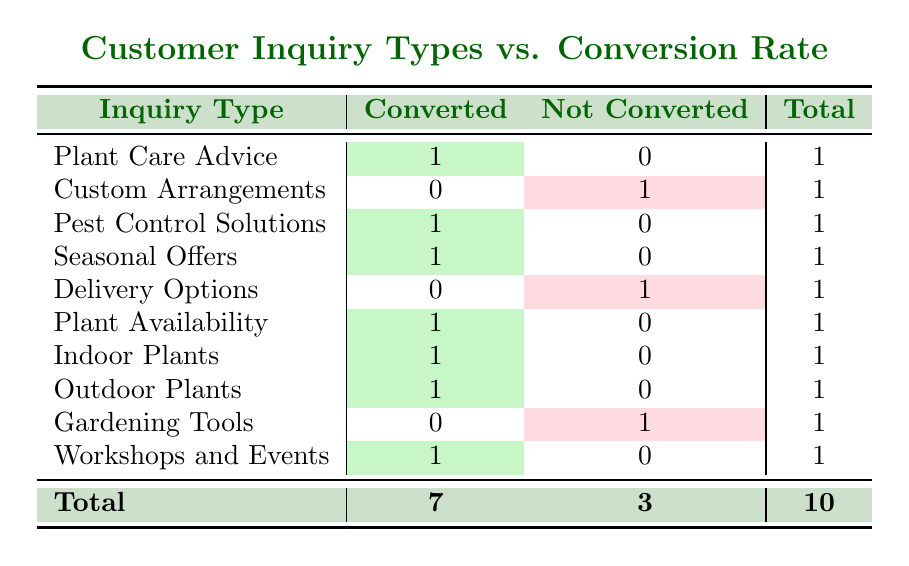What is the total number of inquiries? To find the total number of inquiries, we can look at the "Total" column at the bottom of the table, which sums up all the inquiries. The total is listed as 10.
Answer: 10 How many inquiry types resulted in a conversion to sale? We can look at the "Converted" column and count the number of rows where the value is 1. By counting the highlighted cells in the "Converted" column, we identify 7 inquiries that converted to sales.
Answer: 7 What was the conversion rate for Custom Arrangements? The conversion rate for Custom Arrangements can be determined by checking its row. It shows a "Not Converted" status with a 1 in the "Not Converted" column, indicating zero conversions out of one inquiry. Thus, the conversion rate is 0%.
Answer: 0% Which inquiry type had the highest conversion rate? To identify the inquiry type with the highest conversion rate, we check each row. Since all inquiries except Custom Arrangements, Delivery Options, and Gardening Tools converted, those types with conversions (1.0 for 7 inquiries and 0 for 3) will indicate the highest conversion rate is 100%, and this applies to multiple types.
Answer: Plant Care Advice, Pest Control Solutions, Seasonal Offers, Plant Availability, Indoor Plants, Outdoor Plants, Workshops and Events Did any inquiries result in no sales? By reviewing the "Not Converted" column, we see inquiries for Custom Arrangements, Delivery Options, and Gardening Tools have a value of 1. Therefore, it is true that some inquiries did not convert to sales.
Answer: Yes What percentage of inquiries about Plant Care Advice converted to sales? The total for Plant Care Advice is 1 inquiry, with 1 converted inquiry and 0 not converted. Therefore, the percentage of inquiries converted can be calculated as (1 converted / 1 total) x 100 = 100%.
Answer: 100% How many inquiries related to gardening tools did not convert? Checking the Gardening Tools row, we observe that it has a count of 1 in the "Not Converted" column, indicating this is the total number of inquiries about gardening tools that did not convert to sales.
Answer: 1 What is the average conversion rate of all inquiries? To find the average conversion rate, we calculate the total converted inquiries (7) divided by the total inquiries (10), which gives us a conversion rate of 7/10 = 0.7 or 70%.
Answer: 70% 